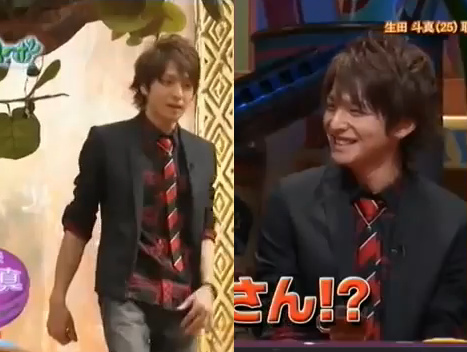Does the man's hair seem to be short? No, the man's hair does not appear to be short. 